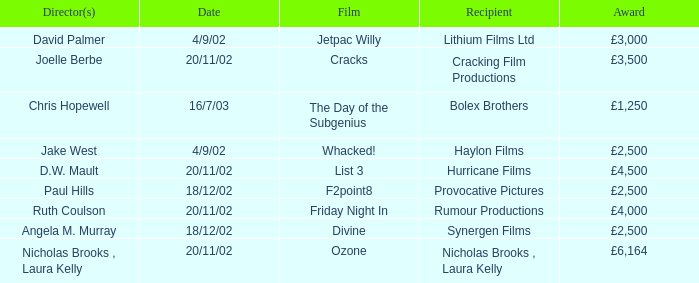Who won an award of £3,000 on 4/9/02? Lithium Films Ltd. 